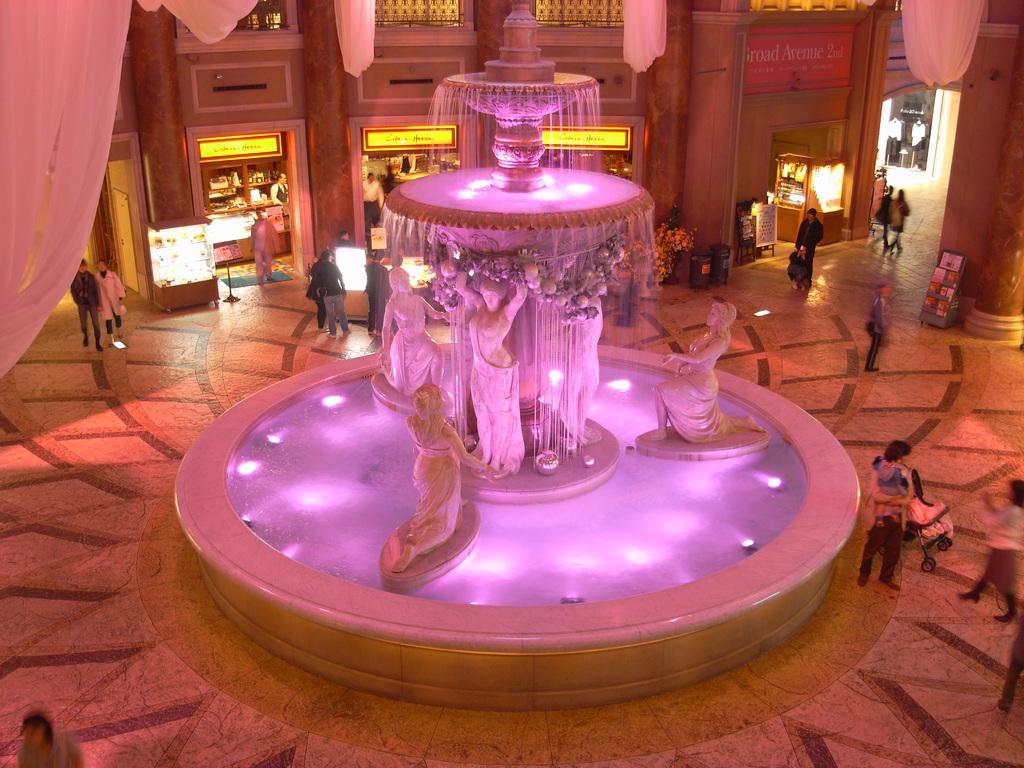How would you summarize this image in a sentence or two? In the middle of the image we can see a water fountain. Surrounding the fountain few people are standing and walking. At the top of the image there is wall and there are some stores. In the top left corner of the image we can see some clothes. 